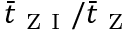Convert formula to latex. <formula><loc_0><loc_0><loc_500><loc_500>\bar { t } _ { Z I } / \bar { t } _ { Z }</formula> 